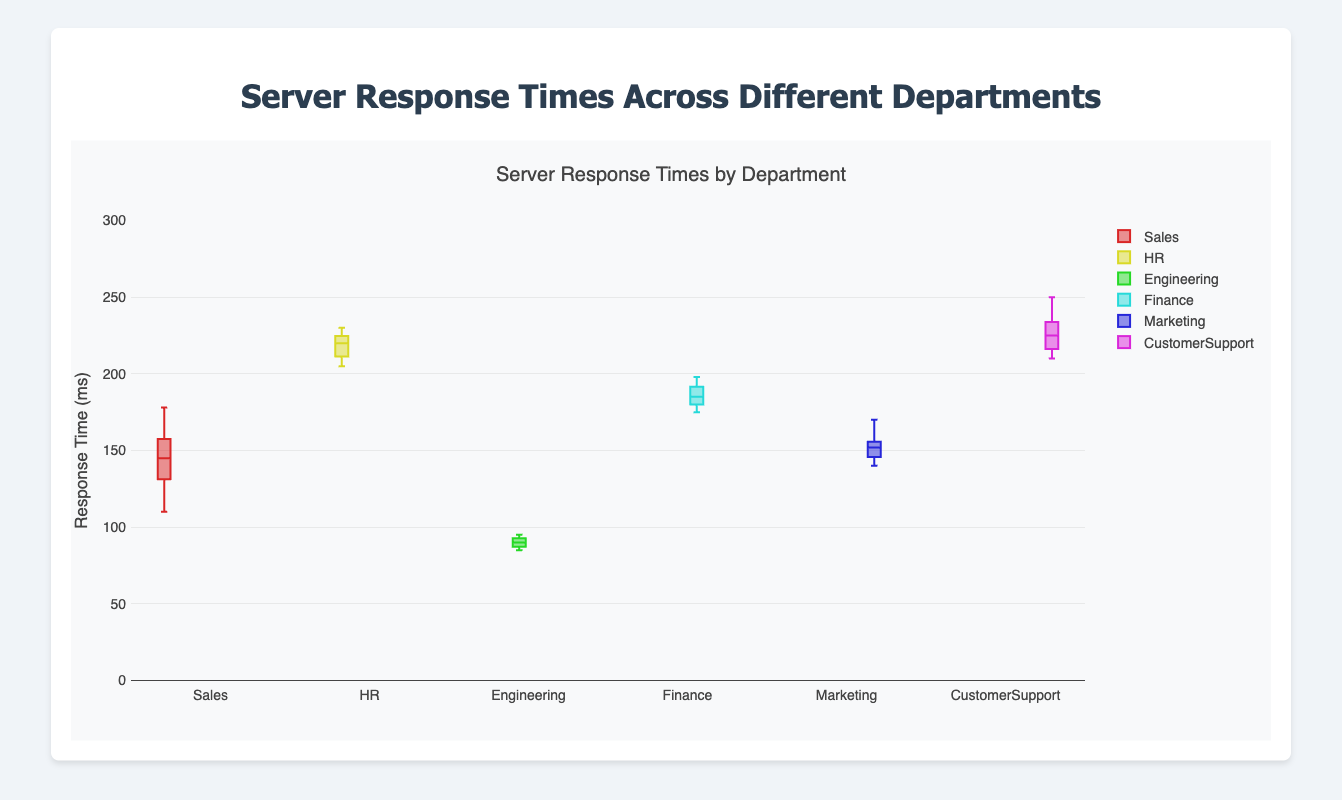What is the title of the figure? The title of the figure is displayed at the top of the plot.
Answer: Server Response Times by Department What does the y-axis represent? The label on the y-axis shows what it represents.
Answer: Response Time (ms) Which department has the highest median server response time? The median is indicated by the line inside each box in the box plot. By looking at the line positions, the box for CustomerSupport has the highest median.
Answer: CustomerSupport Which department has the lowest median server response time? The median is indicated by the line inside each box in the box plot. By looking at the line positions, the box for Engineering has the lowest median.
Answer: Engineering What is the interquartile range (IQR) for the Finance department? The IQR is the range between the first quartile (Q1, bottom edge of the box) and the third quartile (Q3, top edge of the box). For the Finance department, identify Q3 and Q1 from the box and subtract Q1 from Q3.
Answer: Approximately 16 (Q3 ~ 192, Q1 ~ 176) Which department shows the most variability in server response times? Variability can be assessed by observing the length of the box and whiskers. The HR department shows a larger spread within the box and whiskers compared to others.
Answer: HR Which department has response times with the least spread? The department with the smallest box and shorter whiskers indicates the least spread.
Answer: Engineering Are there any suspected outliers in the Marketing department's response times? Outliers are identified by points outside the whiskers of the box plot. In the Marketing department, there is at least one point marked as an outlier above the top whisker.
Answer: Yes How does the median of the Marketing department compare to the Sales department? Compare the position of the lines within the boxes of the Marketing and Sales departments. The median of Marketing is slightly higher than the median of Sales.
Answer: Marketing is slightly higher Which two departments have the closest median server response times? Compare the positions of the median lines across all departments. The Sales and Marketing departments have medians that are very close to each other.
Answer: Sales and Marketing 